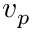<formula> <loc_0><loc_0><loc_500><loc_500>v _ { p }</formula> 